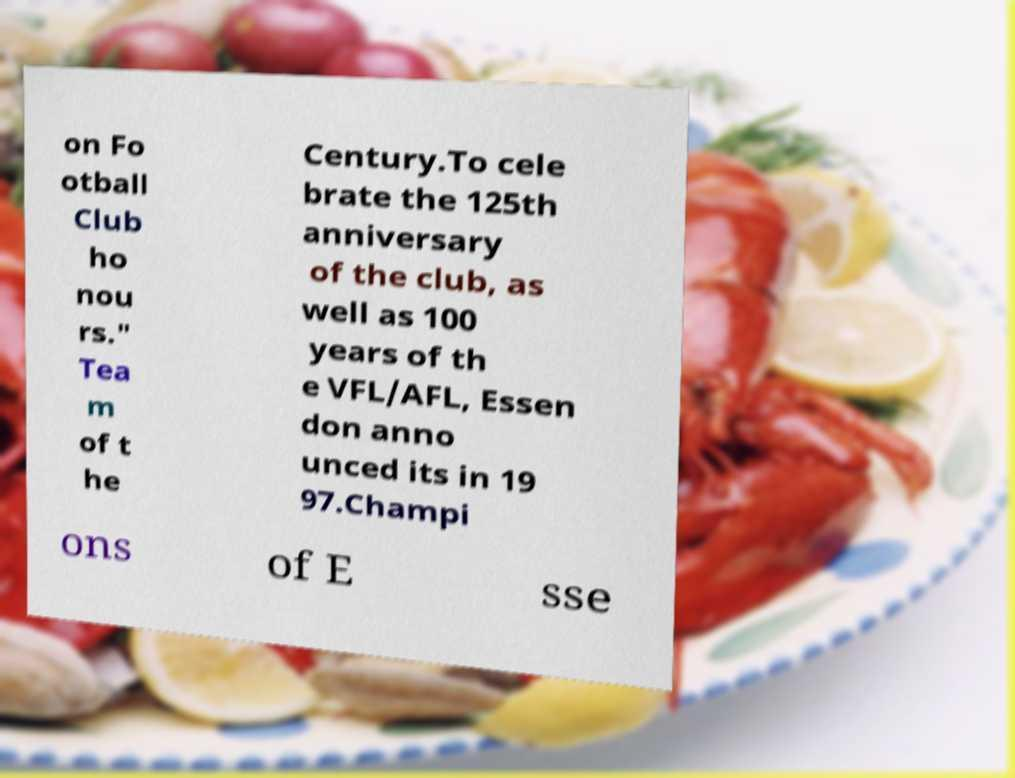Can you read and provide the text displayed in the image?This photo seems to have some interesting text. Can you extract and type it out for me? on Fo otball Club ho nou rs." Tea m of t he Century.To cele brate the 125th anniversary of the club, as well as 100 years of th e VFL/AFL, Essen don anno unced its in 19 97.Champi ons of E sse 